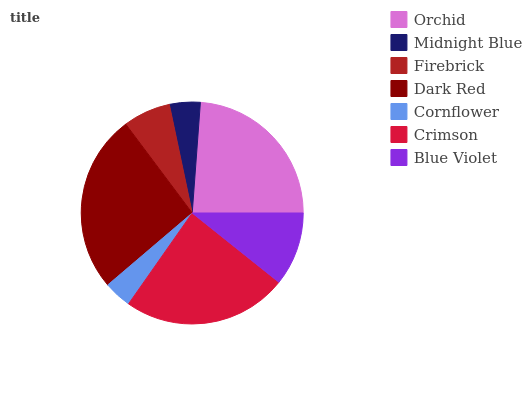Is Cornflower the minimum?
Answer yes or no. Yes. Is Dark Red the maximum?
Answer yes or no. Yes. Is Midnight Blue the minimum?
Answer yes or no. No. Is Midnight Blue the maximum?
Answer yes or no. No. Is Orchid greater than Midnight Blue?
Answer yes or no. Yes. Is Midnight Blue less than Orchid?
Answer yes or no. Yes. Is Midnight Blue greater than Orchid?
Answer yes or no. No. Is Orchid less than Midnight Blue?
Answer yes or no. No. Is Blue Violet the high median?
Answer yes or no. Yes. Is Blue Violet the low median?
Answer yes or no. Yes. Is Orchid the high median?
Answer yes or no. No. Is Crimson the low median?
Answer yes or no. No. 